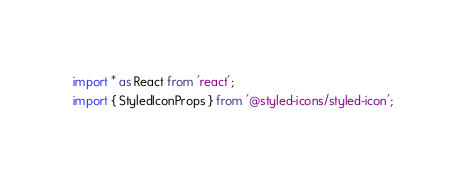<code> <loc_0><loc_0><loc_500><loc_500><_TypeScript_>import * as React from 'react';
import { StyledIconProps } from '@styled-icons/styled-icon';</code> 